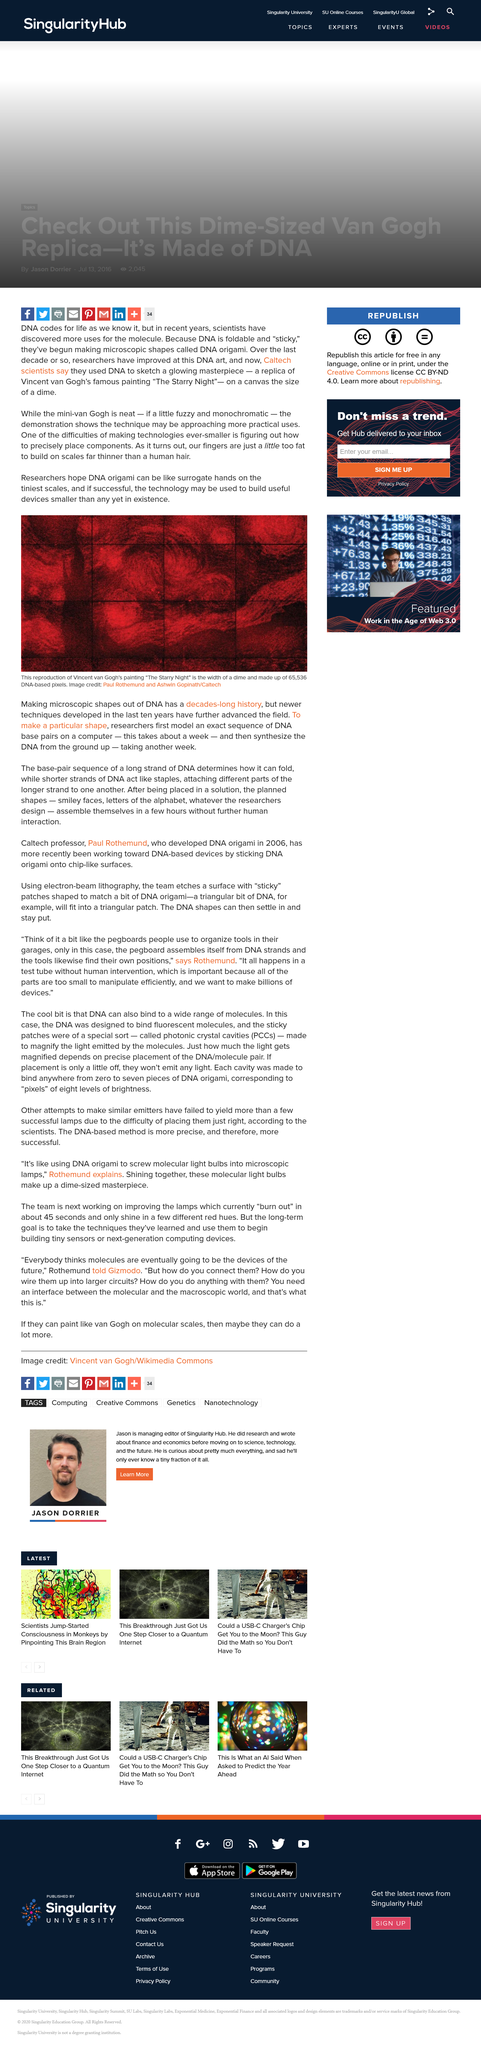Highlight a few significant elements in this photo. The replica of Vincent van Gogh's "The Starry Night" on canvas was the size of a dime. Vincent van Gogh's painting "The Starry Night" was reproduced on canvas with 65,536 DNA-based pixels, which used a digital process to create the image. Scientists from the California Institute of Technology (Caltech) have used DNA to create a glowing masterpiece of Vincent van Gogh's famous painting "The Starry Night. 